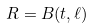Convert formula to latex. <formula><loc_0><loc_0><loc_500><loc_500>R = B ( t , \ell )</formula> 